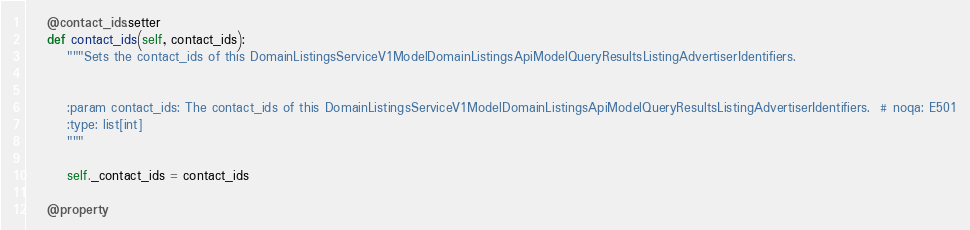Convert code to text. <code><loc_0><loc_0><loc_500><loc_500><_Python_>    @contact_ids.setter
    def contact_ids(self, contact_ids):
        """Sets the contact_ids of this DomainListingsServiceV1ModelDomainListingsApiModelQueryResultsListingAdvertiserIdentifiers.


        :param contact_ids: The contact_ids of this DomainListingsServiceV1ModelDomainListingsApiModelQueryResultsListingAdvertiserIdentifiers.  # noqa: E501
        :type: list[int]
        """

        self._contact_ids = contact_ids

    @property</code> 